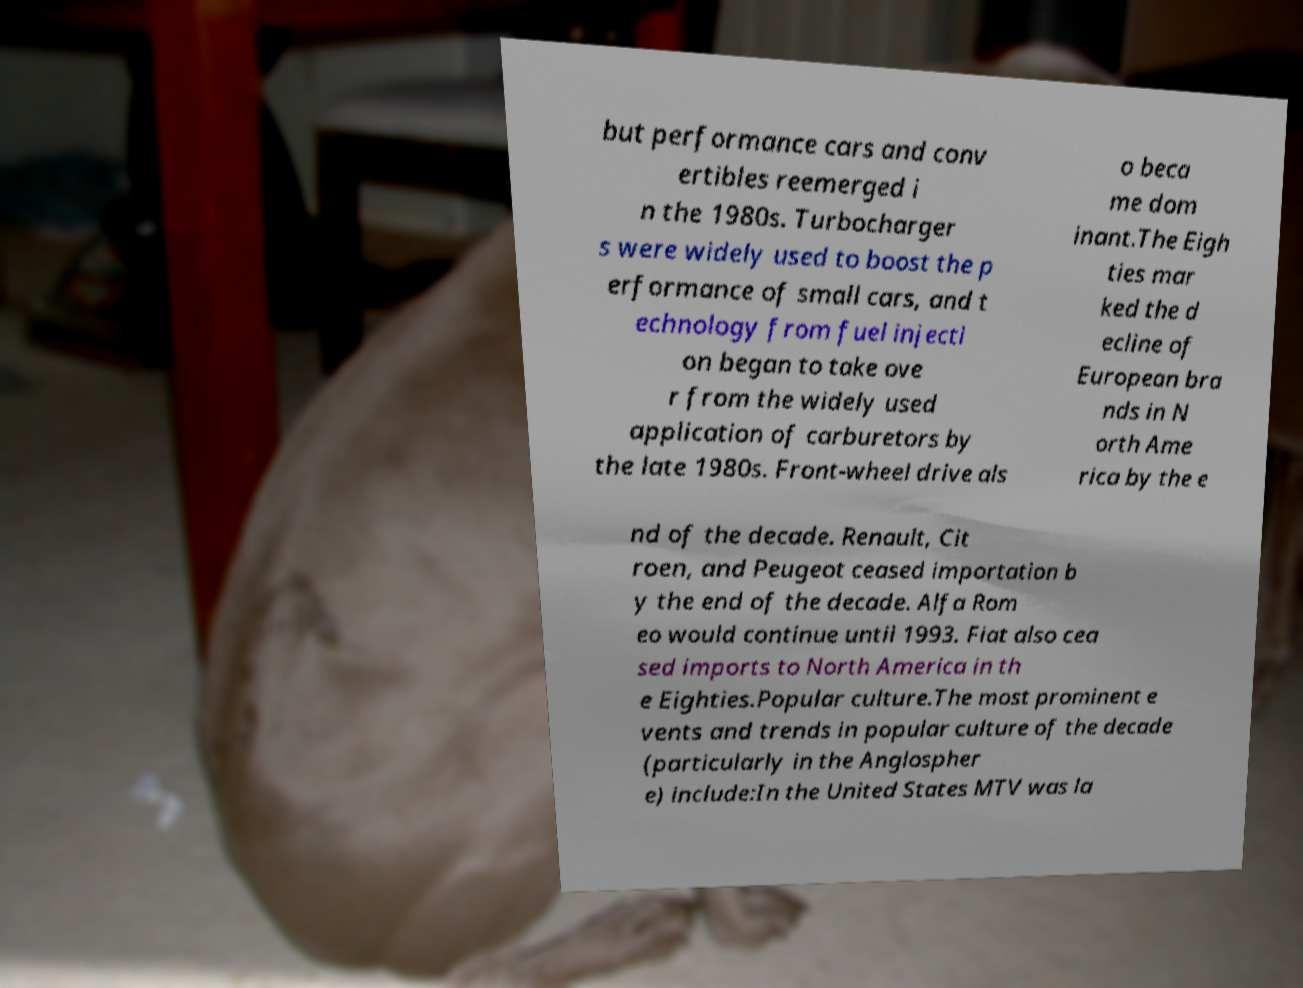What messages or text are displayed in this image? I need them in a readable, typed format. but performance cars and conv ertibles reemerged i n the 1980s. Turbocharger s were widely used to boost the p erformance of small cars, and t echnology from fuel injecti on began to take ove r from the widely used application of carburetors by the late 1980s. Front-wheel drive als o beca me dom inant.The Eigh ties mar ked the d ecline of European bra nds in N orth Ame rica by the e nd of the decade. Renault, Cit roen, and Peugeot ceased importation b y the end of the decade. Alfa Rom eo would continue until 1993. Fiat also cea sed imports to North America in th e Eighties.Popular culture.The most prominent e vents and trends in popular culture of the decade (particularly in the Anglospher e) include:In the United States MTV was la 